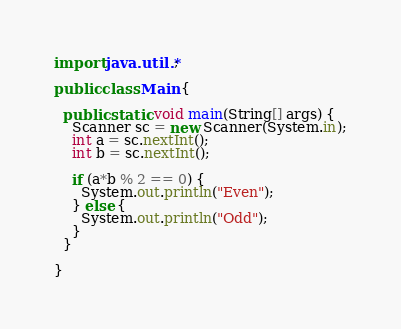Convert code to text. <code><loc_0><loc_0><loc_500><loc_500><_Java_>import java.util.*;

public class Main {

  public static void main(String[] args) {
    Scanner sc = new Scanner(System.in);
    int a = sc.nextInt();
    int b = sc.nextInt();

    if (a*b % 2 == 0) {
      System.out.println("Even");
    } else {
      System.out.println("Odd");
    }
  }

}
</code> 